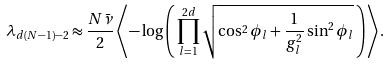Convert formula to latex. <formula><loc_0><loc_0><loc_500><loc_500>\lambda _ { d ( N - 1 ) - 2 } \approx \frac { N \bar { \nu } } { 2 } \left \langle - \log \left ( \, \prod _ { l = 1 } ^ { 2 d } \sqrt { \cos ^ { 2 } \phi _ { l } + \frac { 1 } { g _ { l } ^ { 2 } } \sin ^ { 2 } \phi _ { l } } \, \right ) \right \rangle .</formula> 